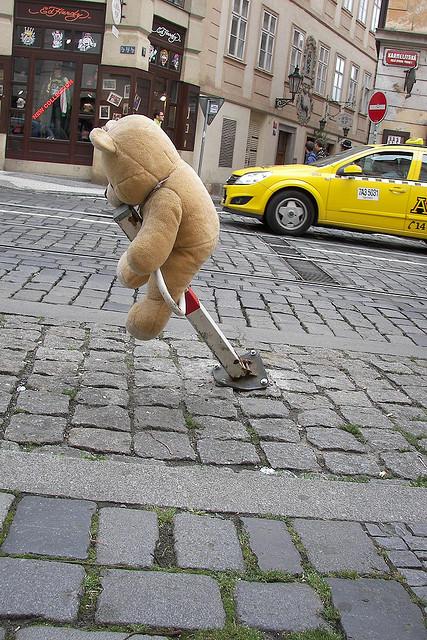Is there traffic?
Answer briefly. Yes. Is there a taxi in the image?
Concise answer only. Yes. What color is the bear?
Quick response, please. Tan. 